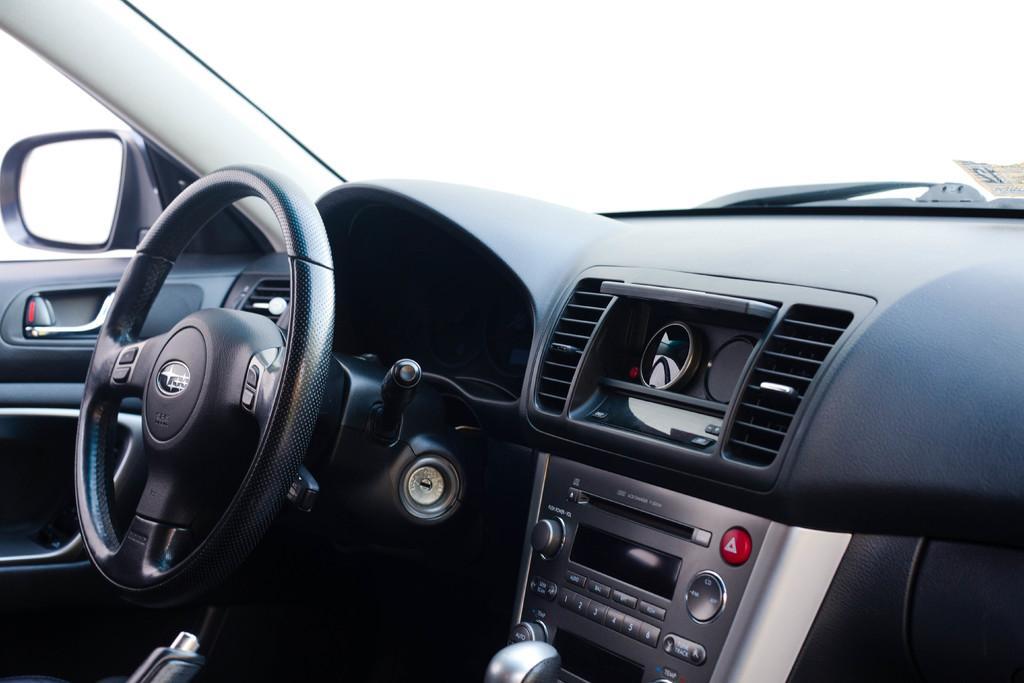How would you summarize this image in a sentence or two? This picture is consists of inside view of a car, which includes steering, mirror, and other parts. 